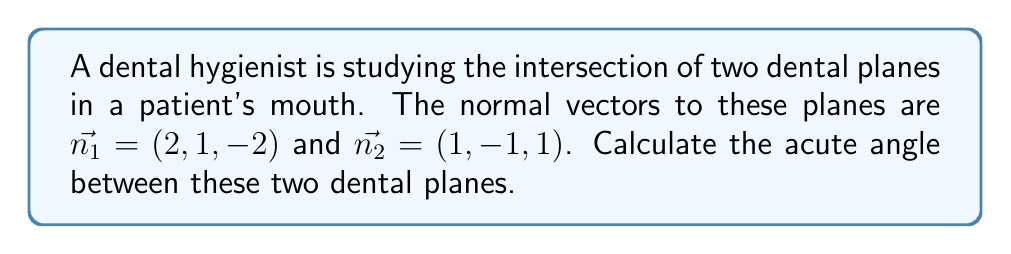Can you answer this question? To find the angle between two planes, we can use the angle between their normal vectors. The formula for the angle $\theta$ between two vectors $\vec{a}$ and $\vec{b}$ is:

$$\cos \theta = \frac{\vec{a} \cdot \vec{b}}{|\vec{a}||\vec{b}|}$$

Where $\vec{a} \cdot \vec{b}$ is the dot product and $|\vec{a}|$ and $|\vec{b}|$ are the magnitudes of the vectors.

Step 1: Calculate the dot product of $\vec{n_1}$ and $\vec{n_2}$
$$\vec{n_1} \cdot \vec{n_2} = (2)(1) + (1)(-1) + (-2)(1) = 2 - 1 - 2 = -1$$

Step 2: Calculate the magnitudes of $\vec{n_1}$ and $\vec{n_2}$
$$|\vec{n_1}| = \sqrt{2^2 + 1^2 + (-2)^2} = \sqrt{4 + 1 + 4} = \sqrt{9} = 3$$
$$|\vec{n_2}| = \sqrt{1^2 + (-1)^2 + 1^2} = \sqrt{1 + 1 + 1} = \sqrt{3}$$

Step 3: Apply the formula
$$\cos \theta = \frac{-1}{3\sqrt{3}}$$

Step 4: Take the inverse cosine (arccos) of both sides
$$\theta = \arccos\left(\frac{-1}{3\sqrt{3}}\right)$$

Step 5: Calculate the result (in radians)
$$\theta \approx 1.8234$$

Step 6: Convert to degrees
$$\theta \approx 1.8234 \times \frac{180}{\pi} \approx 104.48°$$

The acute angle is the complement of this angle:
$$\text{Acute angle} = 180° - 104.48° = 75.52°$$
Answer: The acute angle between the two dental planes is approximately 75.52°. 